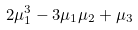Convert formula to latex. <formula><loc_0><loc_0><loc_500><loc_500>2 \mu _ { 1 } ^ { 3 } - 3 \mu _ { 1 } \mu _ { 2 } + \mu _ { 3 }</formula> 